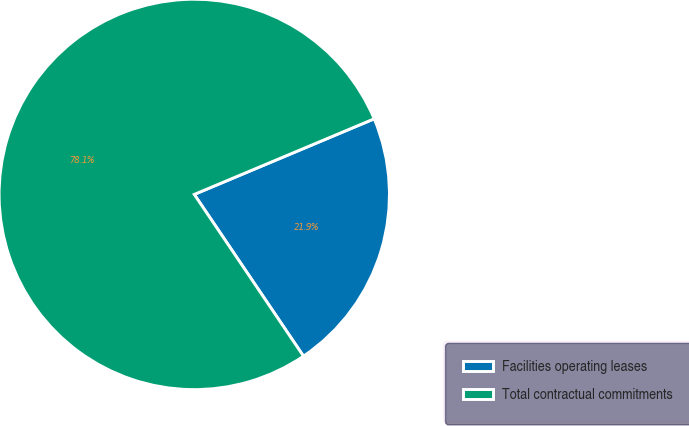<chart> <loc_0><loc_0><loc_500><loc_500><pie_chart><fcel>Facilities operating leases<fcel>Total contractual commitments<nl><fcel>21.88%<fcel>78.12%<nl></chart> 